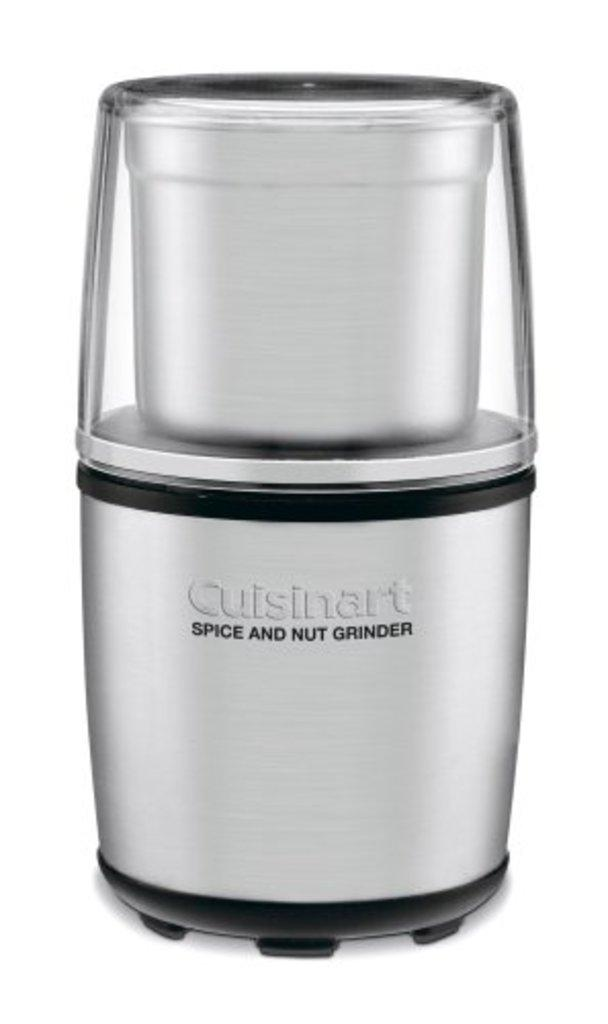Provide a one-sentence caption for the provided image. A kitchen appliance with the words Cuisinart spice and nut grinder written on it. 